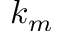<formula> <loc_0><loc_0><loc_500><loc_500>k _ { m }</formula> 